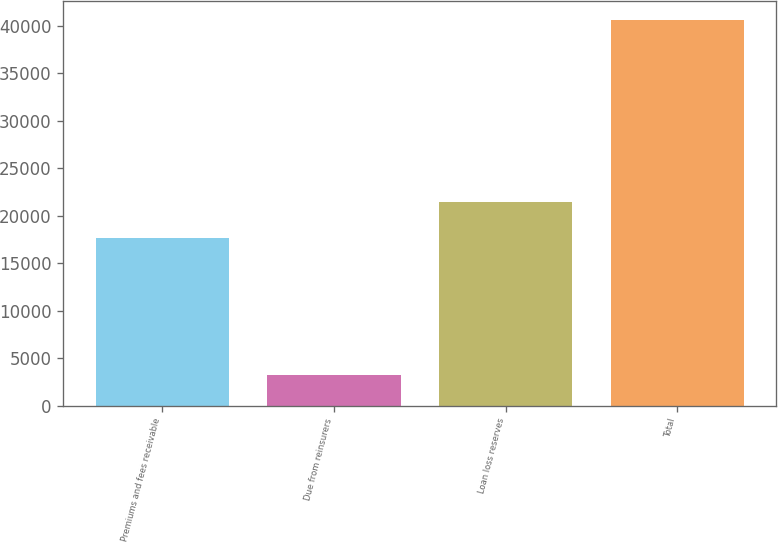Convert chart. <chart><loc_0><loc_0><loc_500><loc_500><bar_chart><fcel>Premiums and fees receivable<fcel>Due from reinsurers<fcel>Loan loss reserves<fcel>Total<nl><fcel>17666<fcel>3169<fcel>21413.1<fcel>40640<nl></chart> 